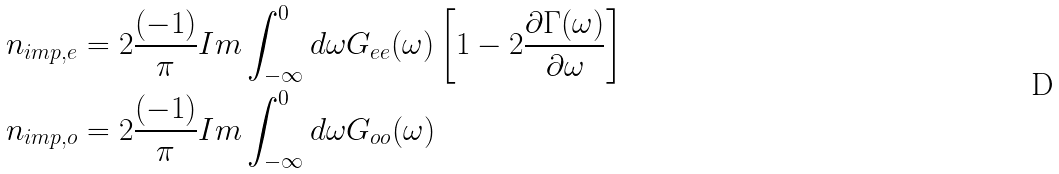Convert formula to latex. <formula><loc_0><loc_0><loc_500><loc_500>n _ { i m p , e } & = 2 \frac { ( - 1 ) } { \pi } I m \int ^ { 0 } _ { - \infty } d \omega G _ { e e } ( \omega ) \left [ 1 - 2 \frac { \partial \Gamma ( \omega ) } { \partial \omega } \right ] \\ n _ { i m p , o } & = 2 \frac { ( - 1 ) } { \pi } I m \int ^ { 0 } _ { - \infty } d \omega G _ { o o } ( \omega )</formula> 